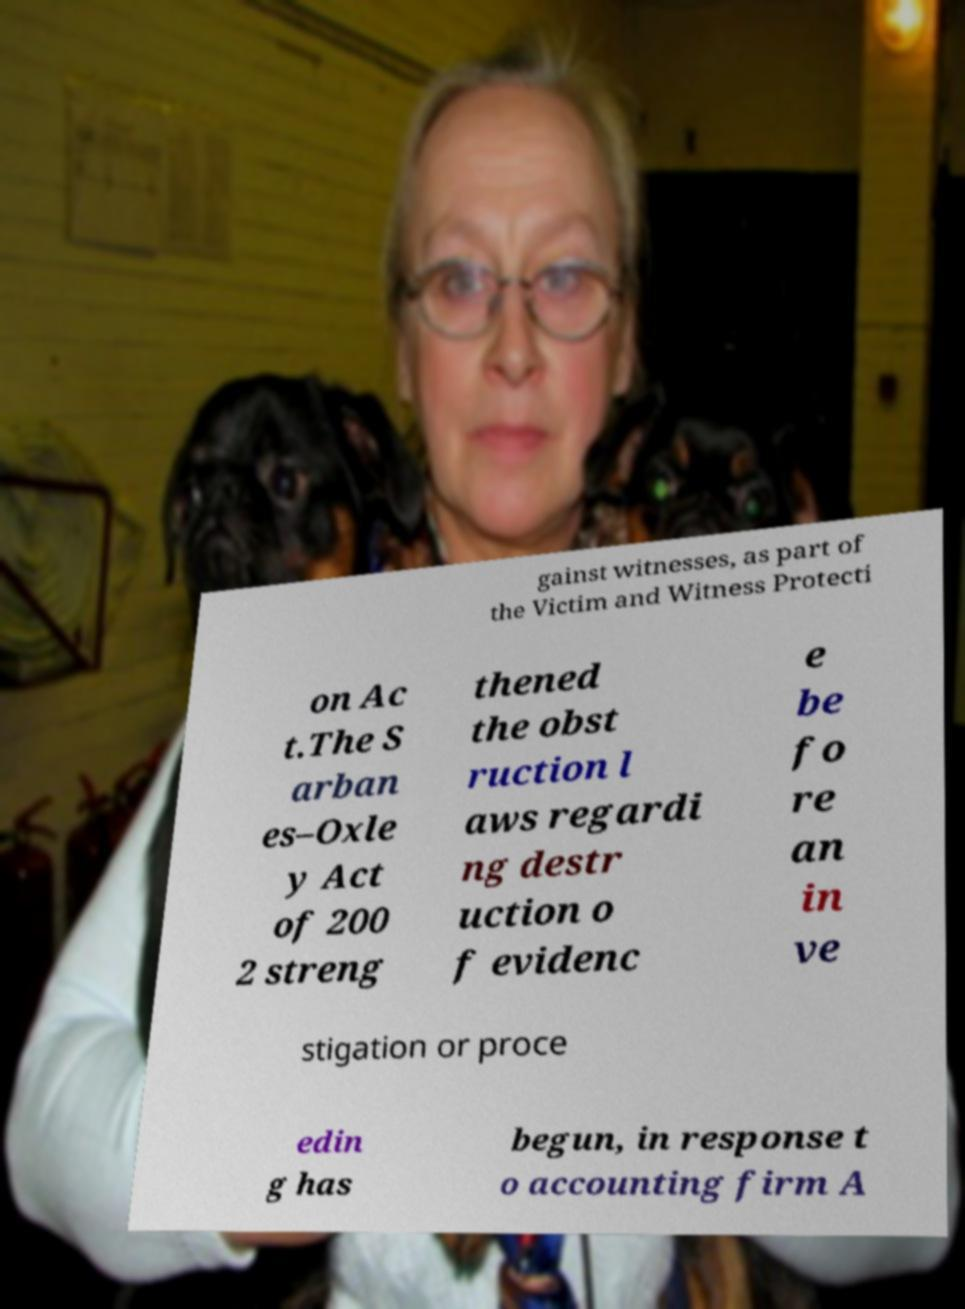Can you read and provide the text displayed in the image?This photo seems to have some interesting text. Can you extract and type it out for me? gainst witnesses, as part of the Victim and Witness Protecti on Ac t.The S arban es–Oxle y Act of 200 2 streng thened the obst ruction l aws regardi ng destr uction o f evidenc e be fo re an in ve stigation or proce edin g has begun, in response t o accounting firm A 